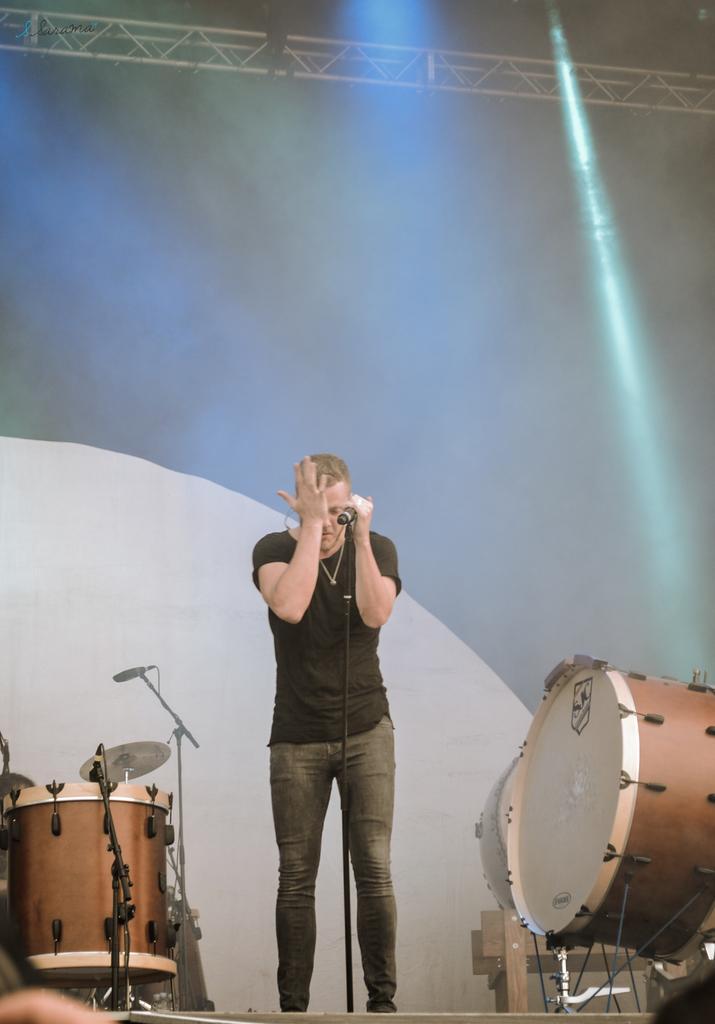In one or two sentences, can you explain what this image depicts? In the foreground of this image, there is a man standing and holding a mic which is attached to the stand. On the right and left, there are drums and the mic stands. In the background, there is blue and white background and few lights at the top. 